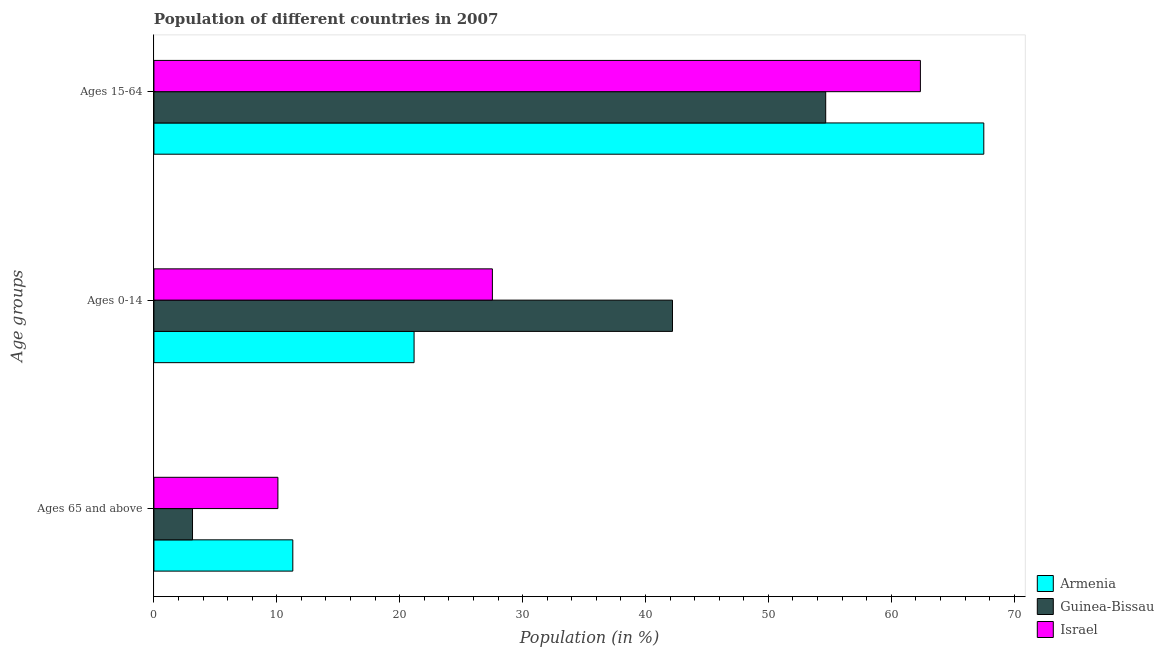How many groups of bars are there?
Offer a very short reply. 3. Are the number of bars per tick equal to the number of legend labels?
Your answer should be compact. Yes. How many bars are there on the 1st tick from the top?
Give a very brief answer. 3. How many bars are there on the 2nd tick from the bottom?
Your answer should be very brief. 3. What is the label of the 2nd group of bars from the top?
Provide a short and direct response. Ages 0-14. What is the percentage of population within the age-group of 65 and above in Armenia?
Provide a short and direct response. 11.3. Across all countries, what is the maximum percentage of population within the age-group of 65 and above?
Your answer should be very brief. 11.3. Across all countries, what is the minimum percentage of population within the age-group of 65 and above?
Ensure brevity in your answer.  3.14. In which country was the percentage of population within the age-group 15-64 maximum?
Offer a very short reply. Armenia. In which country was the percentage of population within the age-group 0-14 minimum?
Provide a short and direct response. Armenia. What is the total percentage of population within the age-group of 65 and above in the graph?
Offer a terse response. 24.53. What is the difference between the percentage of population within the age-group 0-14 in Armenia and that in Israel?
Offer a very short reply. -6.37. What is the difference between the percentage of population within the age-group 0-14 in Armenia and the percentage of population within the age-group of 65 and above in Guinea-Bissau?
Give a very brief answer. 18.03. What is the average percentage of population within the age-group 0-14 per country?
Provide a succinct answer. 30.3. What is the difference between the percentage of population within the age-group of 65 and above and percentage of population within the age-group 15-64 in Israel?
Keep it short and to the point. -52.28. What is the ratio of the percentage of population within the age-group 0-14 in Israel to that in Armenia?
Your response must be concise. 1.3. Is the percentage of population within the age-group of 65 and above in Israel less than that in Guinea-Bissau?
Offer a terse response. No. What is the difference between the highest and the second highest percentage of population within the age-group of 65 and above?
Provide a succinct answer. 1.21. What is the difference between the highest and the lowest percentage of population within the age-group 15-64?
Give a very brief answer. 12.86. In how many countries, is the percentage of population within the age-group of 65 and above greater than the average percentage of population within the age-group of 65 and above taken over all countries?
Offer a terse response. 2. What does the 2nd bar from the top in Ages 15-64 represents?
Your answer should be very brief. Guinea-Bissau. Are all the bars in the graph horizontal?
Provide a short and direct response. Yes. Are the values on the major ticks of X-axis written in scientific E-notation?
Your answer should be very brief. No. Where does the legend appear in the graph?
Your answer should be compact. Bottom right. How many legend labels are there?
Your answer should be compact. 3. What is the title of the graph?
Your answer should be very brief. Population of different countries in 2007. What is the label or title of the X-axis?
Ensure brevity in your answer.  Population (in %). What is the label or title of the Y-axis?
Offer a terse response. Age groups. What is the Population (in %) of Armenia in Ages 65 and above?
Offer a very short reply. 11.3. What is the Population (in %) in Guinea-Bissau in Ages 65 and above?
Provide a short and direct response. 3.14. What is the Population (in %) in Israel in Ages 65 and above?
Offer a very short reply. 10.09. What is the Population (in %) of Armenia in Ages 0-14?
Ensure brevity in your answer.  21.17. What is the Population (in %) of Guinea-Bissau in Ages 0-14?
Your answer should be very brief. 42.2. What is the Population (in %) of Israel in Ages 0-14?
Provide a short and direct response. 27.54. What is the Population (in %) in Armenia in Ages 15-64?
Your answer should be compact. 67.53. What is the Population (in %) of Guinea-Bissau in Ages 15-64?
Your response must be concise. 54.66. What is the Population (in %) in Israel in Ages 15-64?
Give a very brief answer. 62.37. Across all Age groups, what is the maximum Population (in %) in Armenia?
Offer a terse response. 67.53. Across all Age groups, what is the maximum Population (in %) in Guinea-Bissau?
Your response must be concise. 54.66. Across all Age groups, what is the maximum Population (in %) of Israel?
Keep it short and to the point. 62.37. Across all Age groups, what is the minimum Population (in %) of Armenia?
Ensure brevity in your answer.  11.3. Across all Age groups, what is the minimum Population (in %) in Guinea-Bissau?
Your response must be concise. 3.14. Across all Age groups, what is the minimum Population (in %) of Israel?
Your answer should be very brief. 10.09. What is the total Population (in %) in Israel in the graph?
Your answer should be compact. 100. What is the difference between the Population (in %) of Armenia in Ages 65 and above and that in Ages 0-14?
Offer a terse response. -9.87. What is the difference between the Population (in %) in Guinea-Bissau in Ages 65 and above and that in Ages 0-14?
Offer a terse response. -39.06. What is the difference between the Population (in %) in Israel in Ages 65 and above and that in Ages 0-14?
Provide a succinct answer. -17.45. What is the difference between the Population (in %) in Armenia in Ages 65 and above and that in Ages 15-64?
Your response must be concise. -56.23. What is the difference between the Population (in %) of Guinea-Bissau in Ages 65 and above and that in Ages 15-64?
Make the answer very short. -51.52. What is the difference between the Population (in %) of Israel in Ages 65 and above and that in Ages 15-64?
Your answer should be compact. -52.28. What is the difference between the Population (in %) in Armenia in Ages 0-14 and that in Ages 15-64?
Provide a short and direct response. -46.36. What is the difference between the Population (in %) in Guinea-Bissau in Ages 0-14 and that in Ages 15-64?
Your response must be concise. -12.47. What is the difference between the Population (in %) in Israel in Ages 0-14 and that in Ages 15-64?
Provide a succinct answer. -34.83. What is the difference between the Population (in %) of Armenia in Ages 65 and above and the Population (in %) of Guinea-Bissau in Ages 0-14?
Make the answer very short. -30.89. What is the difference between the Population (in %) in Armenia in Ages 65 and above and the Population (in %) in Israel in Ages 0-14?
Provide a succinct answer. -16.24. What is the difference between the Population (in %) in Guinea-Bissau in Ages 65 and above and the Population (in %) in Israel in Ages 0-14?
Make the answer very short. -24.4. What is the difference between the Population (in %) of Armenia in Ages 65 and above and the Population (in %) of Guinea-Bissau in Ages 15-64?
Make the answer very short. -43.36. What is the difference between the Population (in %) in Armenia in Ages 65 and above and the Population (in %) in Israel in Ages 15-64?
Provide a succinct answer. -51.07. What is the difference between the Population (in %) in Guinea-Bissau in Ages 65 and above and the Population (in %) in Israel in Ages 15-64?
Provide a short and direct response. -59.23. What is the difference between the Population (in %) of Armenia in Ages 0-14 and the Population (in %) of Guinea-Bissau in Ages 15-64?
Offer a terse response. -33.49. What is the difference between the Population (in %) of Armenia in Ages 0-14 and the Population (in %) of Israel in Ages 15-64?
Your answer should be very brief. -41.2. What is the difference between the Population (in %) of Guinea-Bissau in Ages 0-14 and the Population (in %) of Israel in Ages 15-64?
Make the answer very short. -20.17. What is the average Population (in %) of Armenia per Age groups?
Provide a short and direct response. 33.33. What is the average Population (in %) of Guinea-Bissau per Age groups?
Ensure brevity in your answer.  33.33. What is the average Population (in %) in Israel per Age groups?
Your answer should be very brief. 33.33. What is the difference between the Population (in %) of Armenia and Population (in %) of Guinea-Bissau in Ages 65 and above?
Your answer should be compact. 8.16. What is the difference between the Population (in %) of Armenia and Population (in %) of Israel in Ages 65 and above?
Give a very brief answer. 1.21. What is the difference between the Population (in %) in Guinea-Bissau and Population (in %) in Israel in Ages 65 and above?
Give a very brief answer. -6.95. What is the difference between the Population (in %) of Armenia and Population (in %) of Guinea-Bissau in Ages 0-14?
Provide a short and direct response. -21.03. What is the difference between the Population (in %) of Armenia and Population (in %) of Israel in Ages 0-14?
Give a very brief answer. -6.37. What is the difference between the Population (in %) in Guinea-Bissau and Population (in %) in Israel in Ages 0-14?
Offer a very short reply. 14.65. What is the difference between the Population (in %) in Armenia and Population (in %) in Guinea-Bissau in Ages 15-64?
Give a very brief answer. 12.86. What is the difference between the Population (in %) in Armenia and Population (in %) in Israel in Ages 15-64?
Make the answer very short. 5.16. What is the difference between the Population (in %) in Guinea-Bissau and Population (in %) in Israel in Ages 15-64?
Offer a terse response. -7.71. What is the ratio of the Population (in %) in Armenia in Ages 65 and above to that in Ages 0-14?
Keep it short and to the point. 0.53. What is the ratio of the Population (in %) in Guinea-Bissau in Ages 65 and above to that in Ages 0-14?
Ensure brevity in your answer.  0.07. What is the ratio of the Population (in %) of Israel in Ages 65 and above to that in Ages 0-14?
Make the answer very short. 0.37. What is the ratio of the Population (in %) of Armenia in Ages 65 and above to that in Ages 15-64?
Ensure brevity in your answer.  0.17. What is the ratio of the Population (in %) in Guinea-Bissau in Ages 65 and above to that in Ages 15-64?
Ensure brevity in your answer.  0.06. What is the ratio of the Population (in %) in Israel in Ages 65 and above to that in Ages 15-64?
Keep it short and to the point. 0.16. What is the ratio of the Population (in %) in Armenia in Ages 0-14 to that in Ages 15-64?
Ensure brevity in your answer.  0.31. What is the ratio of the Population (in %) in Guinea-Bissau in Ages 0-14 to that in Ages 15-64?
Offer a very short reply. 0.77. What is the ratio of the Population (in %) of Israel in Ages 0-14 to that in Ages 15-64?
Ensure brevity in your answer.  0.44. What is the difference between the highest and the second highest Population (in %) in Armenia?
Your answer should be compact. 46.36. What is the difference between the highest and the second highest Population (in %) of Guinea-Bissau?
Make the answer very short. 12.47. What is the difference between the highest and the second highest Population (in %) of Israel?
Give a very brief answer. 34.83. What is the difference between the highest and the lowest Population (in %) in Armenia?
Provide a succinct answer. 56.23. What is the difference between the highest and the lowest Population (in %) of Guinea-Bissau?
Your response must be concise. 51.52. What is the difference between the highest and the lowest Population (in %) in Israel?
Provide a short and direct response. 52.28. 